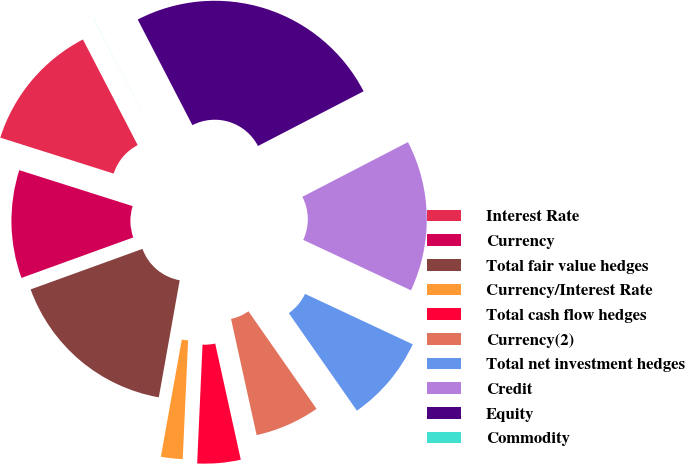Convert chart. <chart><loc_0><loc_0><loc_500><loc_500><pie_chart><fcel>Interest Rate<fcel>Currency<fcel>Total fair value hedges<fcel>Currency/Interest Rate<fcel>Total cash flow hedges<fcel>Currency(2)<fcel>Total net investment hedges<fcel>Credit<fcel>Equity<fcel>Commodity<nl><fcel>12.5%<fcel>10.42%<fcel>16.66%<fcel>2.09%<fcel>4.17%<fcel>6.25%<fcel>8.33%<fcel>14.58%<fcel>24.99%<fcel>0.01%<nl></chart> 